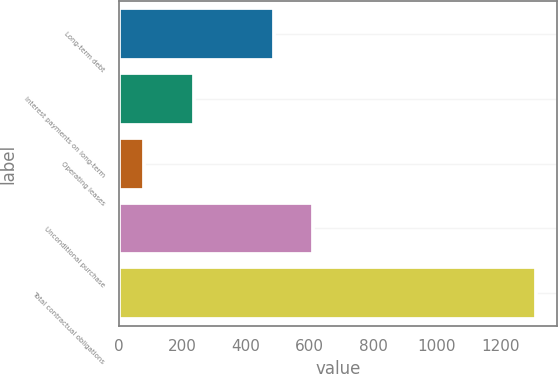Convert chart. <chart><loc_0><loc_0><loc_500><loc_500><bar_chart><fcel>Long-term debt<fcel>Interest payments on long-term<fcel>Operating leases<fcel>Unconditional purchase<fcel>Total contractual obligations<nl><fcel>488<fcel>236<fcel>79<fcel>611.5<fcel>1314<nl></chart> 